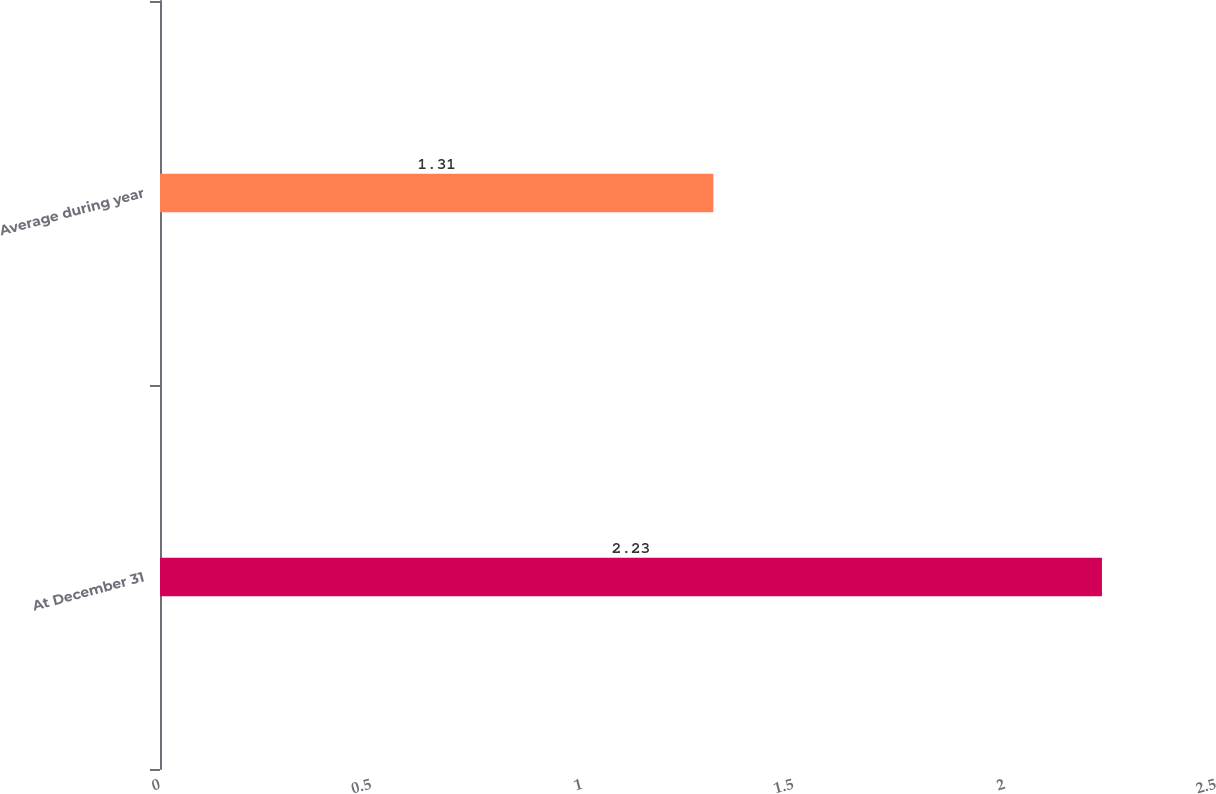Convert chart. <chart><loc_0><loc_0><loc_500><loc_500><bar_chart><fcel>At December 31<fcel>Average during year<nl><fcel>2.23<fcel>1.31<nl></chart> 